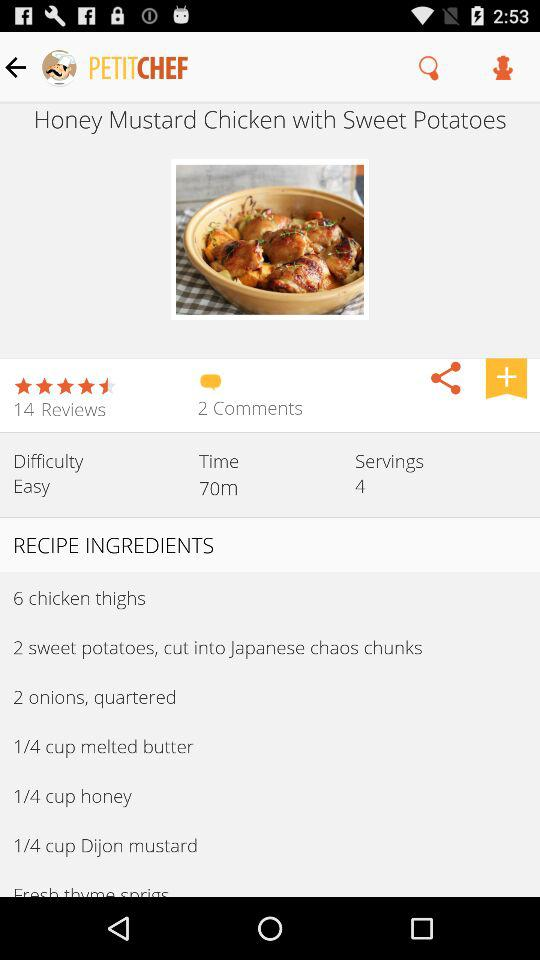How many calories are in this dish?
When the provided information is insufficient, respond with <no answer>. <no answer> 